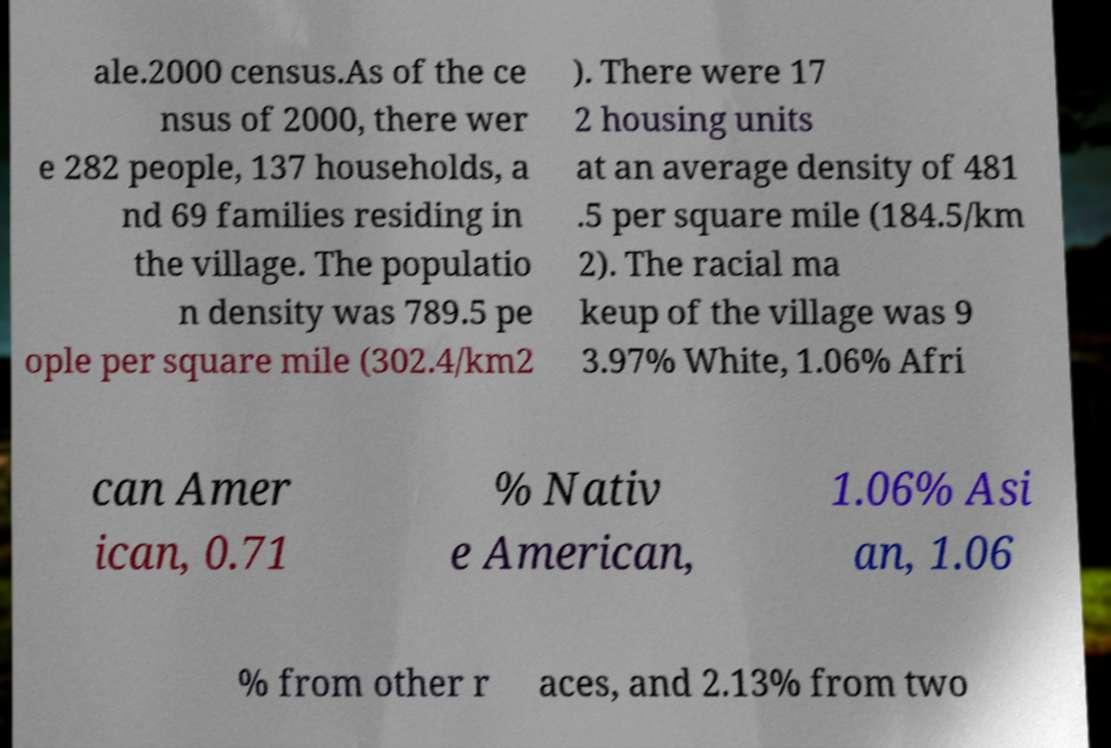For documentation purposes, I need the text within this image transcribed. Could you provide that? ale.2000 census.As of the ce nsus of 2000, there wer e 282 people, 137 households, a nd 69 families residing in the village. The populatio n density was 789.5 pe ople per square mile (302.4/km2 ). There were 17 2 housing units at an average density of 481 .5 per square mile (184.5/km 2). The racial ma keup of the village was 9 3.97% White, 1.06% Afri can Amer ican, 0.71 % Nativ e American, 1.06% Asi an, 1.06 % from other r aces, and 2.13% from two 